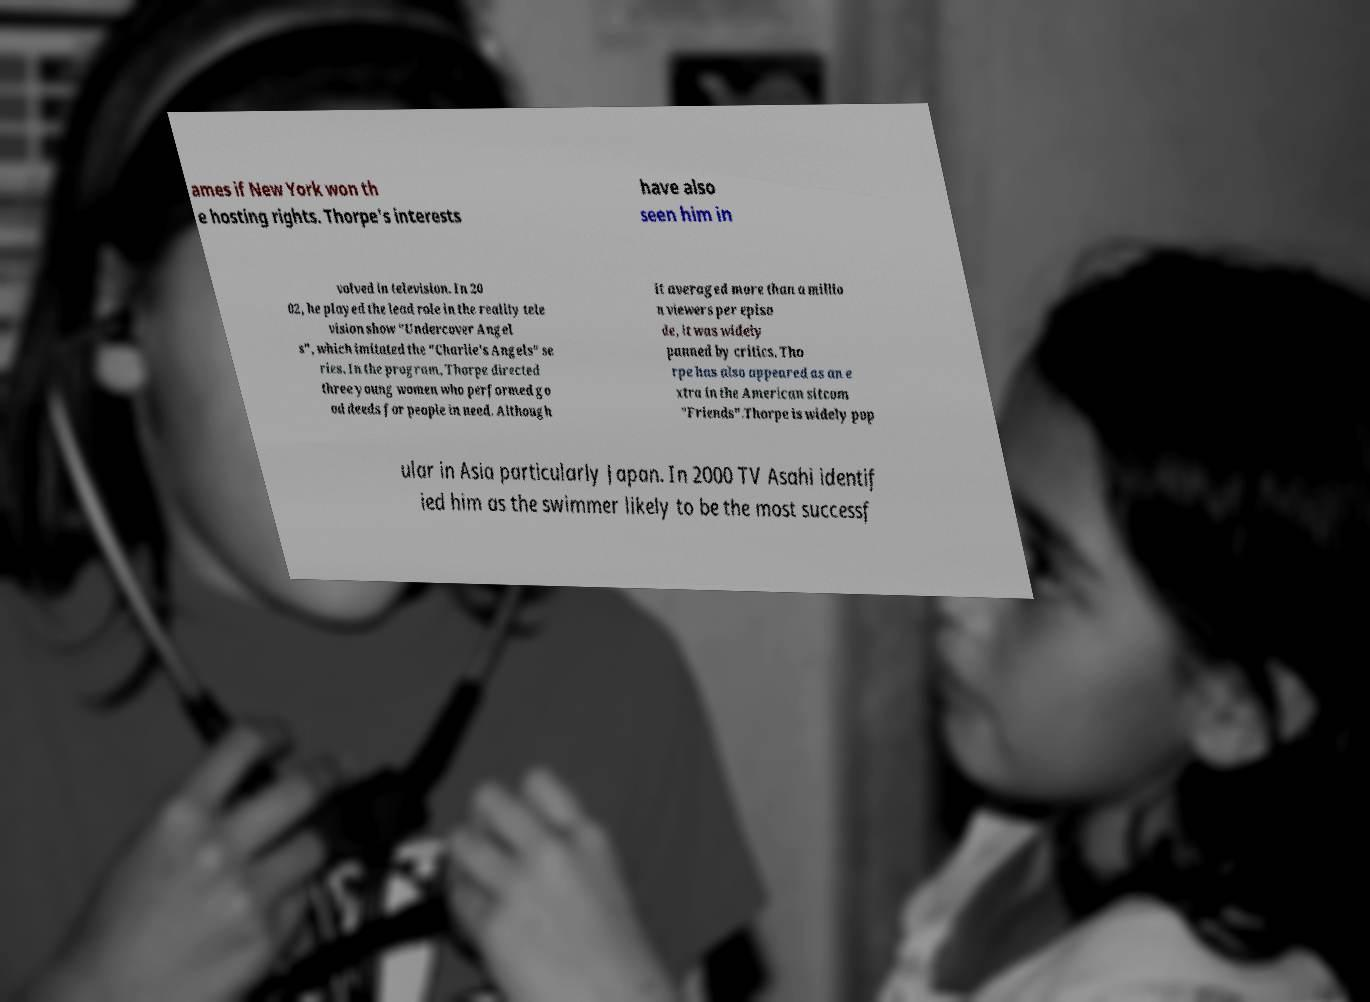There's text embedded in this image that I need extracted. Can you transcribe it verbatim? ames if New York won th e hosting rights. Thorpe's interests have also seen him in volved in television. In 20 02, he played the lead role in the reality tele vision show "Undercover Angel s", which imitated the "Charlie's Angels" se ries. In the program, Thorpe directed three young women who performed go od deeds for people in need. Although it averaged more than a millio n viewers per episo de, it was widely panned by critics. Tho rpe has also appeared as an e xtra in the American sitcom "Friends".Thorpe is widely pop ular in Asia particularly Japan. In 2000 TV Asahi identif ied him as the swimmer likely to be the most successf 